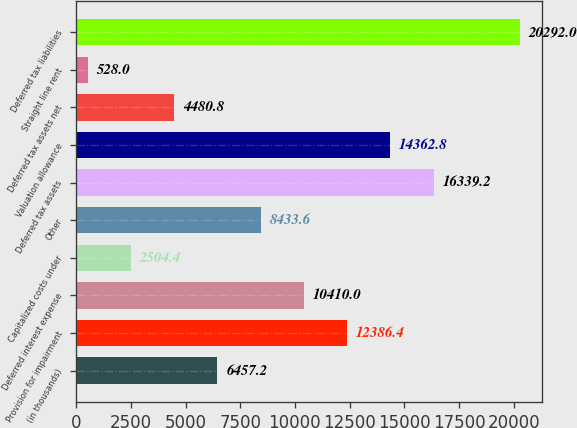<chart> <loc_0><loc_0><loc_500><loc_500><bar_chart><fcel>(in thousands)<fcel>Provision for impairment<fcel>Deferred interest expense<fcel>Capitalized costs under<fcel>Other<fcel>Deferred tax assets<fcel>Valuation allowance<fcel>Deferred tax assets net<fcel>Straight line rent<fcel>Deferred tax liabilities<nl><fcel>6457.2<fcel>12386.4<fcel>10410<fcel>2504.4<fcel>8433.6<fcel>16339.2<fcel>14362.8<fcel>4480.8<fcel>528<fcel>20292<nl></chart> 